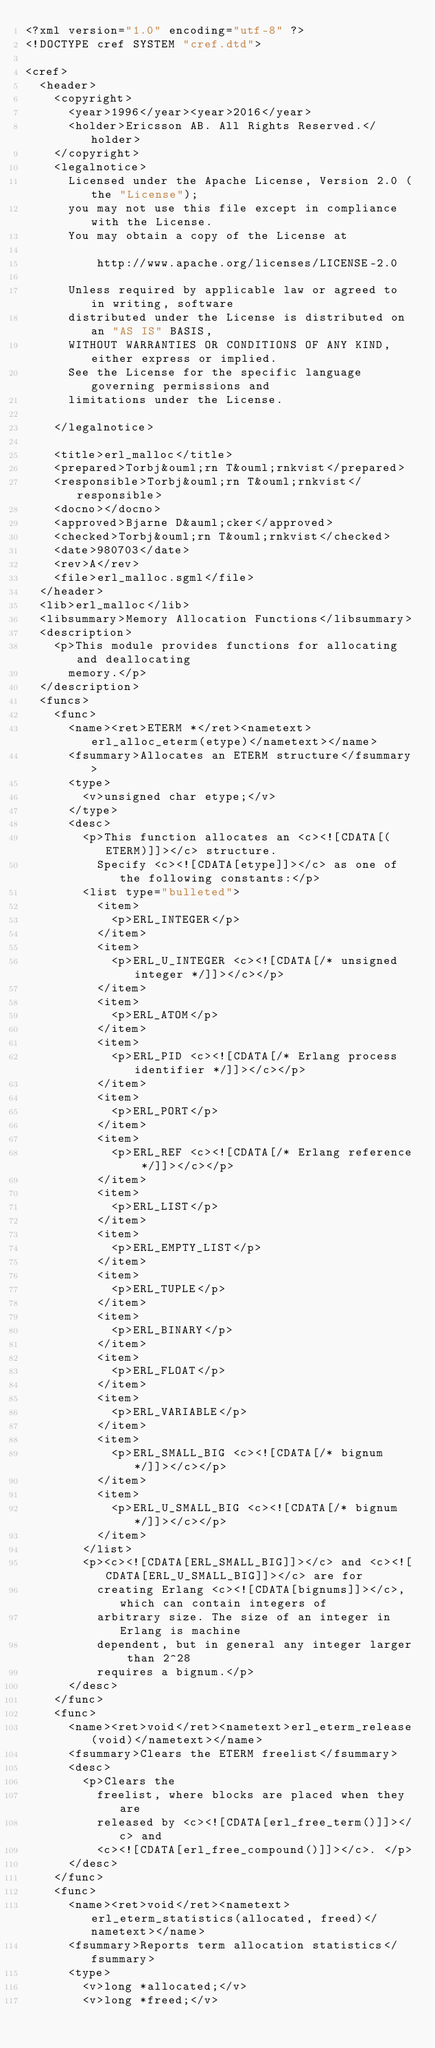Convert code to text. <code><loc_0><loc_0><loc_500><loc_500><_XML_><?xml version="1.0" encoding="utf-8" ?>
<!DOCTYPE cref SYSTEM "cref.dtd">

<cref>
  <header>
    <copyright>
      <year>1996</year><year>2016</year>
      <holder>Ericsson AB. All Rights Reserved.</holder>
    </copyright>
    <legalnotice>
      Licensed under the Apache License, Version 2.0 (the "License");
      you may not use this file except in compliance with the License.
      You may obtain a copy of the License at
 
          http://www.apache.org/licenses/LICENSE-2.0

      Unless required by applicable law or agreed to in writing, software
      distributed under the License is distributed on an "AS IS" BASIS,
      WITHOUT WARRANTIES OR CONDITIONS OF ANY KIND, either express or implied.
      See the License for the specific language governing permissions and
      limitations under the License.
    
    </legalnotice>

    <title>erl_malloc</title>
    <prepared>Torbj&ouml;rn T&ouml;rnkvist</prepared>
    <responsible>Torbj&ouml;rn T&ouml;rnkvist</responsible>
    <docno></docno>
    <approved>Bjarne D&auml;cker</approved>
    <checked>Torbj&ouml;rn T&ouml;rnkvist</checked>
    <date>980703</date>
    <rev>A</rev>
    <file>erl_malloc.sgml</file>
  </header>
  <lib>erl_malloc</lib>
  <libsummary>Memory Allocation Functions</libsummary>
  <description>
    <p>This module provides functions for allocating and deallocating
      memory.</p>
  </description>
  <funcs>
    <func>
      <name><ret>ETERM *</ret><nametext>erl_alloc_eterm(etype)</nametext></name>
      <fsummary>Allocates an ETERM structure</fsummary>
      <type>
        <v>unsigned char etype;</v>
      </type>
      <desc>
        <p>This function allocates an <c><![CDATA[(ETERM)]]></c> structure.
          Specify <c><![CDATA[etype]]></c> as one of the following constants:</p>
        <list type="bulleted">
          <item>
            <p>ERL_INTEGER</p>
          </item>
          <item>
            <p>ERL_U_INTEGER <c><![CDATA[/* unsigned integer */]]></c></p>
          </item>
          <item>
            <p>ERL_ATOM</p>
          </item>
          <item>
            <p>ERL_PID <c><![CDATA[/* Erlang process identifier */]]></c></p>
          </item>
          <item>
            <p>ERL_PORT</p>
          </item>
          <item>
            <p>ERL_REF <c><![CDATA[/* Erlang reference */]]></c></p>
          </item>
          <item>
            <p>ERL_LIST</p>
          </item>
          <item>
            <p>ERL_EMPTY_LIST</p>
          </item>
          <item>
            <p>ERL_TUPLE</p>
          </item>
          <item>
            <p>ERL_BINARY</p>
          </item>
          <item>
            <p>ERL_FLOAT</p>
          </item>
          <item>
            <p>ERL_VARIABLE</p>
          </item>
          <item>
            <p>ERL_SMALL_BIG <c><![CDATA[/* bignum */]]></c></p>
          </item>
          <item>
            <p>ERL_U_SMALL_BIG <c><![CDATA[/* bignum */]]></c></p>
          </item>
        </list>
        <p><c><![CDATA[ERL_SMALL_BIG]]></c> and <c><![CDATA[ERL_U_SMALL_BIG]]></c> are for
          creating Erlang <c><![CDATA[bignums]]></c>, which can contain integers of
          arbitrary size. The size of an integer in Erlang is machine
          dependent, but in general any integer larger than 2^28
          requires a bignum.</p>
      </desc>
    </func>
    <func>
      <name><ret>void</ret><nametext>erl_eterm_release(void)</nametext></name>
      <fsummary>Clears the ETERM freelist</fsummary>
      <desc>
        <p>Clears the 
          freelist, where blocks are placed when they are
          released by <c><![CDATA[erl_free_term()]]></c> and
          <c><![CDATA[erl_free_compound()]]></c>. </p>
      </desc>
    </func>
    <func>
      <name><ret>void</ret><nametext>erl_eterm_statistics(allocated, freed)</nametext></name>
      <fsummary>Reports term allocation statistics</fsummary>
      <type>
        <v>long *allocated;</v>
        <v>long *freed;</v></code> 